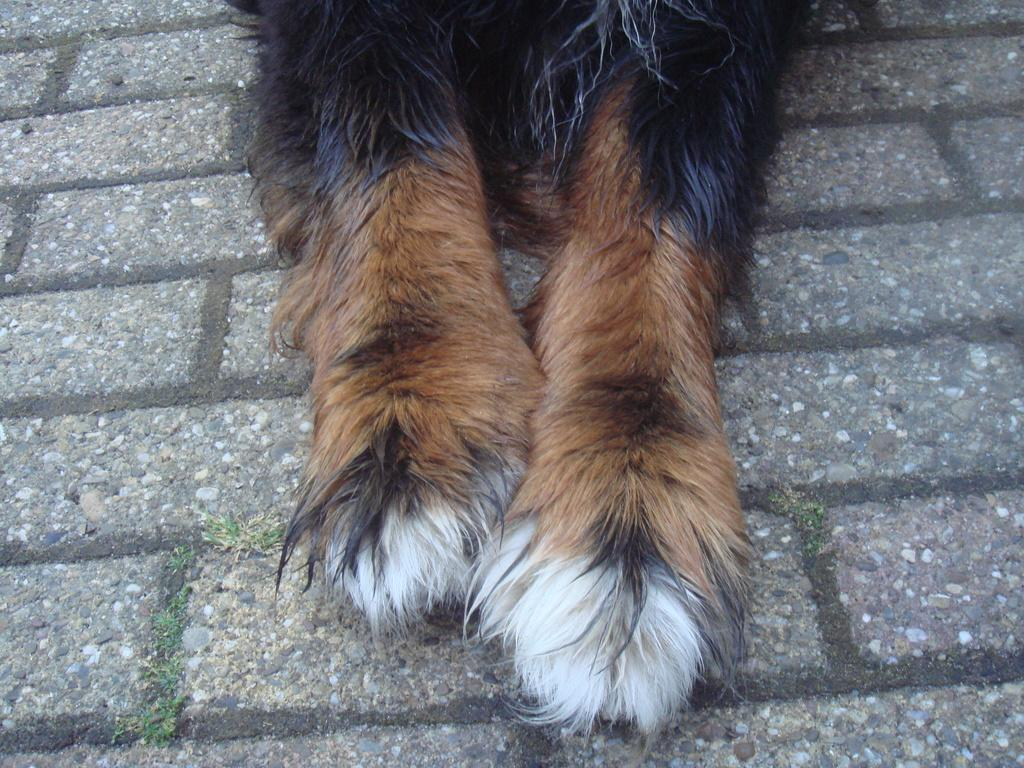What type of animal can be seen in the image? There is an animal that is partially visible in the image. Can you describe the second animal in the image? There is another animal on the surface in the image. What type of vegetation is present in the image? There is grass visible in the image. What type of machine can be seen operating in the background of the image? There is no machine present in the image; it features two animals and grass. What type of oven is visible in the image? There is no oven present in the image. 